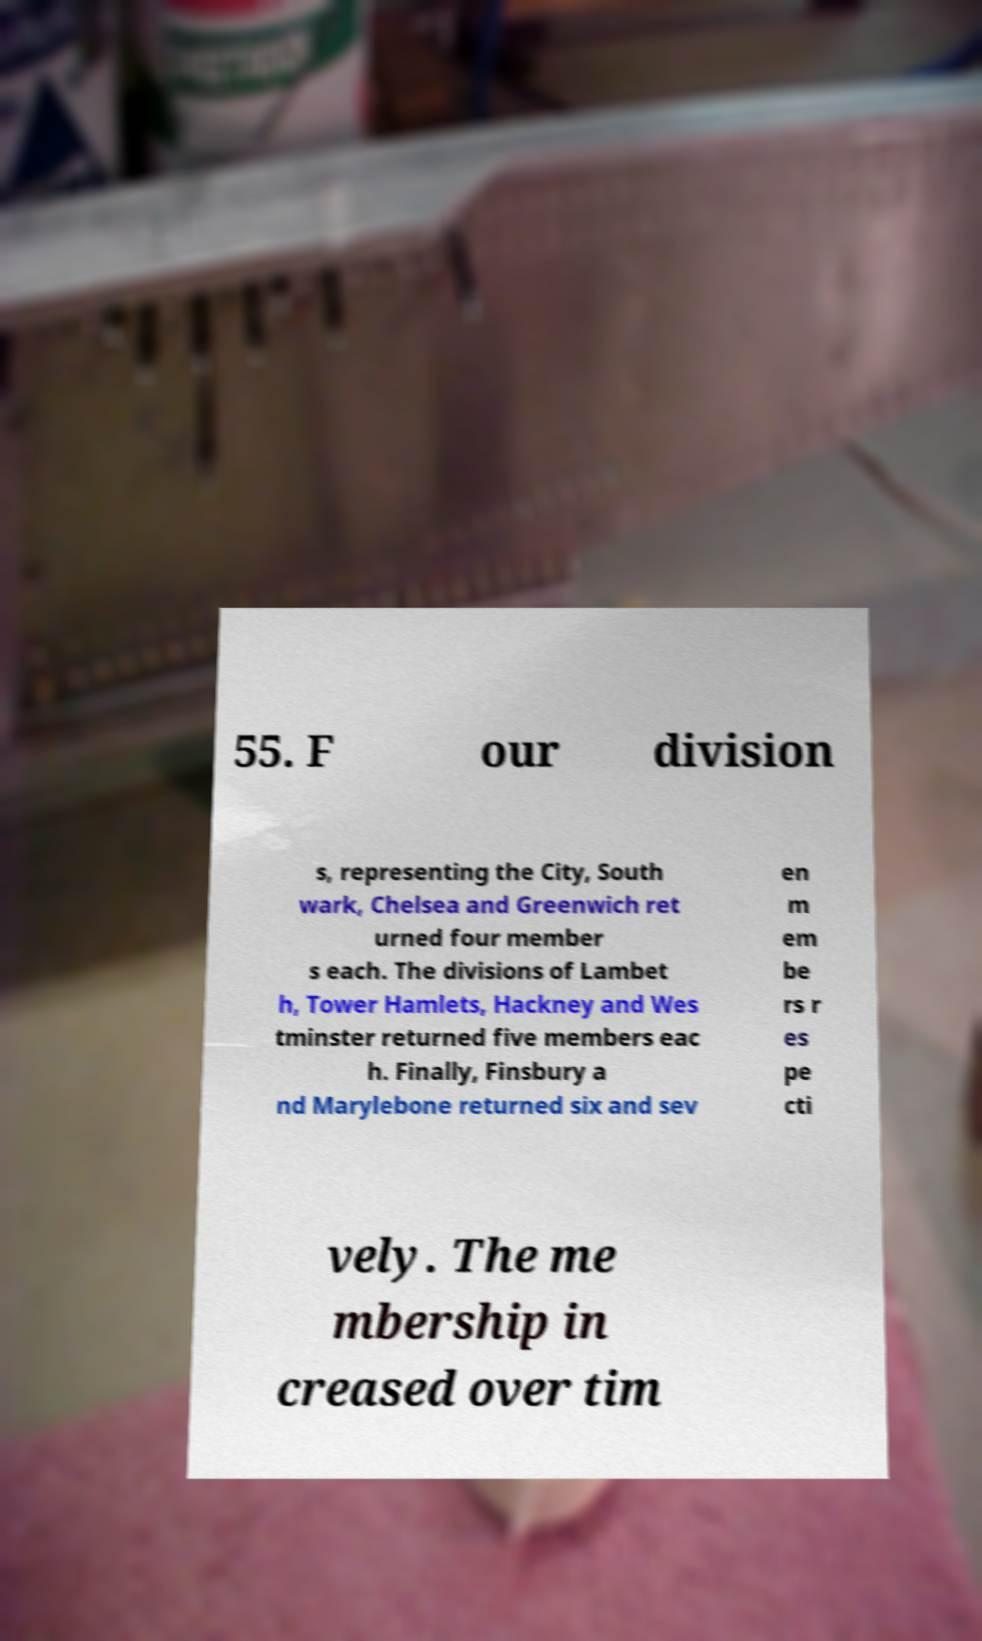Can you read and provide the text displayed in the image?This photo seems to have some interesting text. Can you extract and type it out for me? 55. F our division s, representing the City, South wark, Chelsea and Greenwich ret urned four member s each. The divisions of Lambet h, Tower Hamlets, Hackney and Wes tminster returned five members eac h. Finally, Finsbury a nd Marylebone returned six and sev en m em be rs r es pe cti vely. The me mbership in creased over tim 